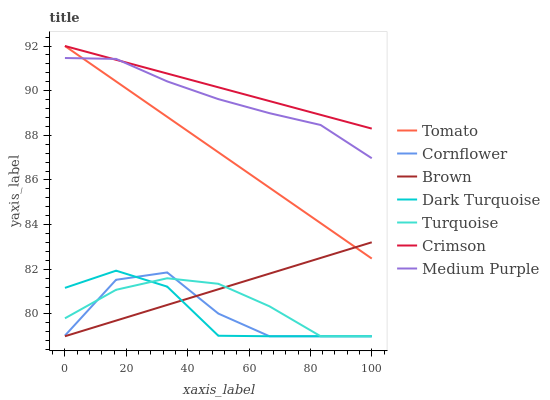Does Dark Turquoise have the minimum area under the curve?
Answer yes or no. Yes. Does Crimson have the maximum area under the curve?
Answer yes or no. Yes. Does Cornflower have the minimum area under the curve?
Answer yes or no. No. Does Cornflower have the maximum area under the curve?
Answer yes or no. No. Is Tomato the smoothest?
Answer yes or no. Yes. Is Cornflower the roughest?
Answer yes or no. Yes. Is Turquoise the smoothest?
Answer yes or no. No. Is Turquoise the roughest?
Answer yes or no. No. Does Cornflower have the lowest value?
Answer yes or no. Yes. Does Medium Purple have the lowest value?
Answer yes or no. No. Does Crimson have the highest value?
Answer yes or no. Yes. Does Cornflower have the highest value?
Answer yes or no. No. Is Dark Turquoise less than Tomato?
Answer yes or no. Yes. Is Crimson greater than Cornflower?
Answer yes or no. Yes. Does Crimson intersect Medium Purple?
Answer yes or no. Yes. Is Crimson less than Medium Purple?
Answer yes or no. No. Is Crimson greater than Medium Purple?
Answer yes or no. No. Does Dark Turquoise intersect Tomato?
Answer yes or no. No. 